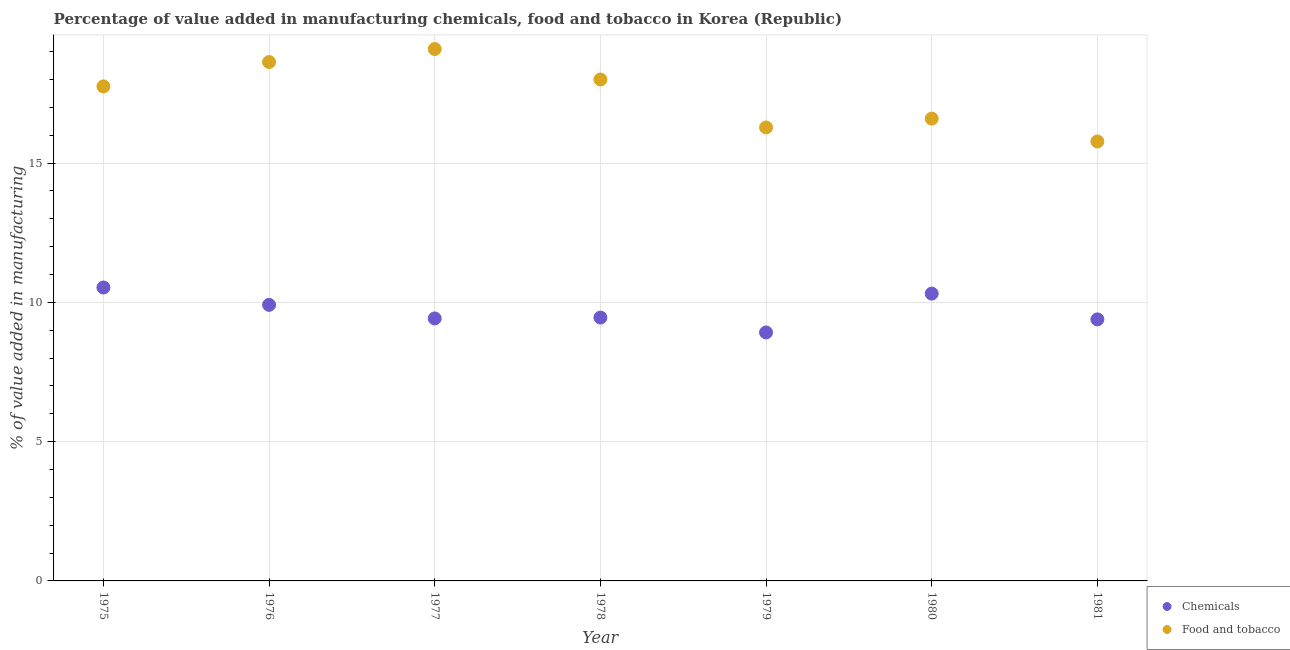How many different coloured dotlines are there?
Your answer should be very brief. 2. What is the value added by  manufacturing chemicals in 1976?
Offer a very short reply. 9.91. Across all years, what is the maximum value added by manufacturing food and tobacco?
Keep it short and to the point. 19.1. Across all years, what is the minimum value added by  manufacturing chemicals?
Keep it short and to the point. 8.92. In which year was the value added by  manufacturing chemicals minimum?
Provide a short and direct response. 1979. What is the total value added by  manufacturing chemicals in the graph?
Offer a terse response. 67.95. What is the difference between the value added by manufacturing food and tobacco in 1976 and that in 1979?
Your answer should be very brief. 2.35. What is the difference between the value added by  manufacturing chemicals in 1975 and the value added by manufacturing food and tobacco in 1980?
Offer a terse response. -6.06. What is the average value added by  manufacturing chemicals per year?
Ensure brevity in your answer.  9.71. In the year 1977, what is the difference between the value added by manufacturing food and tobacco and value added by  manufacturing chemicals?
Give a very brief answer. 9.67. What is the ratio of the value added by manufacturing food and tobacco in 1977 to that in 1981?
Make the answer very short. 1.21. Is the value added by manufacturing food and tobacco in 1975 less than that in 1979?
Ensure brevity in your answer.  No. Is the difference between the value added by  manufacturing chemicals in 1976 and 1979 greater than the difference between the value added by manufacturing food and tobacco in 1976 and 1979?
Provide a short and direct response. No. What is the difference between the highest and the second highest value added by  manufacturing chemicals?
Make the answer very short. 0.22. What is the difference between the highest and the lowest value added by  manufacturing chemicals?
Provide a succinct answer. 1.61. In how many years, is the value added by  manufacturing chemicals greater than the average value added by  manufacturing chemicals taken over all years?
Provide a short and direct response. 3. Is the sum of the value added by manufacturing food and tobacco in 1976 and 1979 greater than the maximum value added by  manufacturing chemicals across all years?
Give a very brief answer. Yes. Does the value added by manufacturing food and tobacco monotonically increase over the years?
Provide a succinct answer. No. Are the values on the major ticks of Y-axis written in scientific E-notation?
Provide a succinct answer. No. Does the graph contain any zero values?
Your answer should be compact. No. How many legend labels are there?
Provide a succinct answer. 2. How are the legend labels stacked?
Provide a short and direct response. Vertical. What is the title of the graph?
Your answer should be very brief. Percentage of value added in manufacturing chemicals, food and tobacco in Korea (Republic). Does "Sanitation services" appear as one of the legend labels in the graph?
Offer a very short reply. No. What is the label or title of the X-axis?
Provide a succinct answer. Year. What is the label or title of the Y-axis?
Your answer should be compact. % of value added in manufacturing. What is the % of value added in manufacturing in Chemicals in 1975?
Provide a short and direct response. 10.53. What is the % of value added in manufacturing of Food and tobacco in 1975?
Your answer should be very brief. 17.76. What is the % of value added in manufacturing of Chemicals in 1976?
Your answer should be very brief. 9.91. What is the % of value added in manufacturing in Food and tobacco in 1976?
Offer a terse response. 18.63. What is the % of value added in manufacturing in Chemicals in 1977?
Your answer should be very brief. 9.42. What is the % of value added in manufacturing in Food and tobacco in 1977?
Offer a very short reply. 19.1. What is the % of value added in manufacturing of Chemicals in 1978?
Keep it short and to the point. 9.46. What is the % of value added in manufacturing of Food and tobacco in 1978?
Ensure brevity in your answer.  18. What is the % of value added in manufacturing of Chemicals in 1979?
Your answer should be very brief. 8.92. What is the % of value added in manufacturing of Food and tobacco in 1979?
Your answer should be compact. 16.28. What is the % of value added in manufacturing in Chemicals in 1980?
Offer a very short reply. 10.31. What is the % of value added in manufacturing in Food and tobacco in 1980?
Make the answer very short. 16.6. What is the % of value added in manufacturing in Chemicals in 1981?
Offer a very short reply. 9.39. What is the % of value added in manufacturing in Food and tobacco in 1981?
Ensure brevity in your answer.  15.78. Across all years, what is the maximum % of value added in manufacturing of Chemicals?
Give a very brief answer. 10.53. Across all years, what is the maximum % of value added in manufacturing of Food and tobacco?
Give a very brief answer. 19.1. Across all years, what is the minimum % of value added in manufacturing in Chemicals?
Make the answer very short. 8.92. Across all years, what is the minimum % of value added in manufacturing of Food and tobacco?
Provide a short and direct response. 15.78. What is the total % of value added in manufacturing in Chemicals in the graph?
Provide a short and direct response. 67.95. What is the total % of value added in manufacturing of Food and tobacco in the graph?
Your answer should be very brief. 122.14. What is the difference between the % of value added in manufacturing in Chemicals in 1975 and that in 1976?
Make the answer very short. 0.62. What is the difference between the % of value added in manufacturing of Food and tobacco in 1975 and that in 1976?
Ensure brevity in your answer.  -0.87. What is the difference between the % of value added in manufacturing in Chemicals in 1975 and that in 1977?
Your answer should be very brief. 1.11. What is the difference between the % of value added in manufacturing in Food and tobacco in 1975 and that in 1977?
Your response must be concise. -1.34. What is the difference between the % of value added in manufacturing in Chemicals in 1975 and that in 1978?
Offer a terse response. 1.08. What is the difference between the % of value added in manufacturing of Food and tobacco in 1975 and that in 1978?
Make the answer very short. -0.25. What is the difference between the % of value added in manufacturing of Chemicals in 1975 and that in 1979?
Give a very brief answer. 1.61. What is the difference between the % of value added in manufacturing of Food and tobacco in 1975 and that in 1979?
Make the answer very short. 1.47. What is the difference between the % of value added in manufacturing of Chemicals in 1975 and that in 1980?
Your answer should be very brief. 0.22. What is the difference between the % of value added in manufacturing in Food and tobacco in 1975 and that in 1980?
Offer a terse response. 1.16. What is the difference between the % of value added in manufacturing in Chemicals in 1975 and that in 1981?
Your response must be concise. 1.14. What is the difference between the % of value added in manufacturing of Food and tobacco in 1975 and that in 1981?
Offer a terse response. 1.98. What is the difference between the % of value added in manufacturing of Chemicals in 1976 and that in 1977?
Give a very brief answer. 0.49. What is the difference between the % of value added in manufacturing in Food and tobacco in 1976 and that in 1977?
Give a very brief answer. -0.47. What is the difference between the % of value added in manufacturing in Chemicals in 1976 and that in 1978?
Your answer should be compact. 0.46. What is the difference between the % of value added in manufacturing in Food and tobacco in 1976 and that in 1978?
Keep it short and to the point. 0.63. What is the difference between the % of value added in manufacturing of Chemicals in 1976 and that in 1979?
Your response must be concise. 0.99. What is the difference between the % of value added in manufacturing of Food and tobacco in 1976 and that in 1979?
Provide a short and direct response. 2.35. What is the difference between the % of value added in manufacturing of Chemicals in 1976 and that in 1980?
Make the answer very short. -0.4. What is the difference between the % of value added in manufacturing of Food and tobacco in 1976 and that in 1980?
Keep it short and to the point. 2.03. What is the difference between the % of value added in manufacturing of Chemicals in 1976 and that in 1981?
Your answer should be compact. 0.52. What is the difference between the % of value added in manufacturing of Food and tobacco in 1976 and that in 1981?
Offer a very short reply. 2.85. What is the difference between the % of value added in manufacturing of Chemicals in 1977 and that in 1978?
Give a very brief answer. -0.03. What is the difference between the % of value added in manufacturing in Food and tobacco in 1977 and that in 1978?
Offer a terse response. 1.09. What is the difference between the % of value added in manufacturing in Chemicals in 1977 and that in 1979?
Your response must be concise. 0.5. What is the difference between the % of value added in manufacturing in Food and tobacco in 1977 and that in 1979?
Give a very brief answer. 2.81. What is the difference between the % of value added in manufacturing in Chemicals in 1977 and that in 1980?
Make the answer very short. -0.89. What is the difference between the % of value added in manufacturing of Food and tobacco in 1977 and that in 1980?
Offer a terse response. 2.5. What is the difference between the % of value added in manufacturing in Chemicals in 1977 and that in 1981?
Your answer should be compact. 0.03. What is the difference between the % of value added in manufacturing in Food and tobacco in 1977 and that in 1981?
Your answer should be compact. 3.32. What is the difference between the % of value added in manufacturing in Chemicals in 1978 and that in 1979?
Your answer should be very brief. 0.54. What is the difference between the % of value added in manufacturing of Food and tobacco in 1978 and that in 1979?
Provide a succinct answer. 1.72. What is the difference between the % of value added in manufacturing of Chemicals in 1978 and that in 1980?
Make the answer very short. -0.86. What is the difference between the % of value added in manufacturing of Food and tobacco in 1978 and that in 1980?
Give a very brief answer. 1.4. What is the difference between the % of value added in manufacturing of Chemicals in 1978 and that in 1981?
Ensure brevity in your answer.  0.07. What is the difference between the % of value added in manufacturing of Food and tobacco in 1978 and that in 1981?
Offer a very short reply. 2.22. What is the difference between the % of value added in manufacturing of Chemicals in 1979 and that in 1980?
Your answer should be compact. -1.39. What is the difference between the % of value added in manufacturing in Food and tobacco in 1979 and that in 1980?
Your answer should be compact. -0.32. What is the difference between the % of value added in manufacturing of Chemicals in 1979 and that in 1981?
Ensure brevity in your answer.  -0.47. What is the difference between the % of value added in manufacturing in Food and tobacco in 1979 and that in 1981?
Ensure brevity in your answer.  0.5. What is the difference between the % of value added in manufacturing of Chemicals in 1980 and that in 1981?
Offer a very short reply. 0.92. What is the difference between the % of value added in manufacturing of Food and tobacco in 1980 and that in 1981?
Give a very brief answer. 0.82. What is the difference between the % of value added in manufacturing in Chemicals in 1975 and the % of value added in manufacturing in Food and tobacco in 1976?
Your answer should be compact. -8.1. What is the difference between the % of value added in manufacturing of Chemicals in 1975 and the % of value added in manufacturing of Food and tobacco in 1977?
Offer a very short reply. -8.56. What is the difference between the % of value added in manufacturing in Chemicals in 1975 and the % of value added in manufacturing in Food and tobacco in 1978?
Offer a terse response. -7.47. What is the difference between the % of value added in manufacturing in Chemicals in 1975 and the % of value added in manufacturing in Food and tobacco in 1979?
Give a very brief answer. -5.75. What is the difference between the % of value added in manufacturing in Chemicals in 1975 and the % of value added in manufacturing in Food and tobacco in 1980?
Offer a terse response. -6.06. What is the difference between the % of value added in manufacturing in Chemicals in 1975 and the % of value added in manufacturing in Food and tobacco in 1981?
Keep it short and to the point. -5.24. What is the difference between the % of value added in manufacturing of Chemicals in 1976 and the % of value added in manufacturing of Food and tobacco in 1977?
Provide a succinct answer. -9.18. What is the difference between the % of value added in manufacturing of Chemicals in 1976 and the % of value added in manufacturing of Food and tobacco in 1978?
Your response must be concise. -8.09. What is the difference between the % of value added in manufacturing in Chemicals in 1976 and the % of value added in manufacturing in Food and tobacco in 1979?
Offer a very short reply. -6.37. What is the difference between the % of value added in manufacturing in Chemicals in 1976 and the % of value added in manufacturing in Food and tobacco in 1980?
Your answer should be compact. -6.69. What is the difference between the % of value added in manufacturing of Chemicals in 1976 and the % of value added in manufacturing of Food and tobacco in 1981?
Your response must be concise. -5.87. What is the difference between the % of value added in manufacturing of Chemicals in 1977 and the % of value added in manufacturing of Food and tobacco in 1978?
Provide a short and direct response. -8.58. What is the difference between the % of value added in manufacturing in Chemicals in 1977 and the % of value added in manufacturing in Food and tobacco in 1979?
Give a very brief answer. -6.86. What is the difference between the % of value added in manufacturing in Chemicals in 1977 and the % of value added in manufacturing in Food and tobacco in 1980?
Your answer should be very brief. -7.17. What is the difference between the % of value added in manufacturing in Chemicals in 1977 and the % of value added in manufacturing in Food and tobacco in 1981?
Make the answer very short. -6.35. What is the difference between the % of value added in manufacturing in Chemicals in 1978 and the % of value added in manufacturing in Food and tobacco in 1979?
Provide a succinct answer. -6.83. What is the difference between the % of value added in manufacturing in Chemicals in 1978 and the % of value added in manufacturing in Food and tobacco in 1980?
Provide a short and direct response. -7.14. What is the difference between the % of value added in manufacturing in Chemicals in 1978 and the % of value added in manufacturing in Food and tobacco in 1981?
Provide a short and direct response. -6.32. What is the difference between the % of value added in manufacturing of Chemicals in 1979 and the % of value added in manufacturing of Food and tobacco in 1980?
Offer a terse response. -7.68. What is the difference between the % of value added in manufacturing of Chemicals in 1979 and the % of value added in manufacturing of Food and tobacco in 1981?
Give a very brief answer. -6.86. What is the difference between the % of value added in manufacturing in Chemicals in 1980 and the % of value added in manufacturing in Food and tobacco in 1981?
Offer a very short reply. -5.46. What is the average % of value added in manufacturing of Chemicals per year?
Give a very brief answer. 9.71. What is the average % of value added in manufacturing in Food and tobacco per year?
Provide a short and direct response. 17.45. In the year 1975, what is the difference between the % of value added in manufacturing in Chemicals and % of value added in manufacturing in Food and tobacco?
Make the answer very short. -7.22. In the year 1976, what is the difference between the % of value added in manufacturing of Chemicals and % of value added in manufacturing of Food and tobacco?
Offer a terse response. -8.72. In the year 1977, what is the difference between the % of value added in manufacturing of Chemicals and % of value added in manufacturing of Food and tobacco?
Make the answer very short. -9.67. In the year 1978, what is the difference between the % of value added in manufacturing of Chemicals and % of value added in manufacturing of Food and tobacco?
Offer a terse response. -8.55. In the year 1979, what is the difference between the % of value added in manufacturing in Chemicals and % of value added in manufacturing in Food and tobacco?
Keep it short and to the point. -7.36. In the year 1980, what is the difference between the % of value added in manufacturing in Chemicals and % of value added in manufacturing in Food and tobacco?
Your answer should be compact. -6.28. In the year 1981, what is the difference between the % of value added in manufacturing of Chemicals and % of value added in manufacturing of Food and tobacco?
Your response must be concise. -6.39. What is the ratio of the % of value added in manufacturing of Chemicals in 1975 to that in 1976?
Your answer should be very brief. 1.06. What is the ratio of the % of value added in manufacturing in Food and tobacco in 1975 to that in 1976?
Provide a succinct answer. 0.95. What is the ratio of the % of value added in manufacturing in Chemicals in 1975 to that in 1977?
Offer a terse response. 1.12. What is the ratio of the % of value added in manufacturing of Food and tobacco in 1975 to that in 1977?
Provide a short and direct response. 0.93. What is the ratio of the % of value added in manufacturing in Chemicals in 1975 to that in 1978?
Provide a short and direct response. 1.11. What is the ratio of the % of value added in manufacturing of Food and tobacco in 1975 to that in 1978?
Your answer should be compact. 0.99. What is the ratio of the % of value added in manufacturing of Chemicals in 1975 to that in 1979?
Your answer should be compact. 1.18. What is the ratio of the % of value added in manufacturing of Food and tobacco in 1975 to that in 1979?
Provide a succinct answer. 1.09. What is the ratio of the % of value added in manufacturing in Chemicals in 1975 to that in 1980?
Make the answer very short. 1.02. What is the ratio of the % of value added in manufacturing in Food and tobacco in 1975 to that in 1980?
Offer a very short reply. 1.07. What is the ratio of the % of value added in manufacturing in Chemicals in 1975 to that in 1981?
Offer a very short reply. 1.12. What is the ratio of the % of value added in manufacturing of Food and tobacco in 1975 to that in 1981?
Provide a succinct answer. 1.13. What is the ratio of the % of value added in manufacturing in Chemicals in 1976 to that in 1977?
Provide a short and direct response. 1.05. What is the ratio of the % of value added in manufacturing in Food and tobacco in 1976 to that in 1977?
Your response must be concise. 0.98. What is the ratio of the % of value added in manufacturing of Chemicals in 1976 to that in 1978?
Offer a very short reply. 1.05. What is the ratio of the % of value added in manufacturing in Food and tobacco in 1976 to that in 1978?
Make the answer very short. 1.03. What is the ratio of the % of value added in manufacturing of Food and tobacco in 1976 to that in 1979?
Your response must be concise. 1.14. What is the ratio of the % of value added in manufacturing of Chemicals in 1976 to that in 1980?
Provide a succinct answer. 0.96. What is the ratio of the % of value added in manufacturing of Food and tobacco in 1976 to that in 1980?
Give a very brief answer. 1.12. What is the ratio of the % of value added in manufacturing of Chemicals in 1976 to that in 1981?
Offer a very short reply. 1.06. What is the ratio of the % of value added in manufacturing in Food and tobacco in 1976 to that in 1981?
Your answer should be very brief. 1.18. What is the ratio of the % of value added in manufacturing of Chemicals in 1977 to that in 1978?
Provide a short and direct response. 1. What is the ratio of the % of value added in manufacturing in Food and tobacco in 1977 to that in 1978?
Keep it short and to the point. 1.06. What is the ratio of the % of value added in manufacturing in Chemicals in 1977 to that in 1979?
Provide a succinct answer. 1.06. What is the ratio of the % of value added in manufacturing of Food and tobacco in 1977 to that in 1979?
Ensure brevity in your answer.  1.17. What is the ratio of the % of value added in manufacturing of Chemicals in 1977 to that in 1980?
Provide a short and direct response. 0.91. What is the ratio of the % of value added in manufacturing in Food and tobacco in 1977 to that in 1980?
Ensure brevity in your answer.  1.15. What is the ratio of the % of value added in manufacturing of Food and tobacco in 1977 to that in 1981?
Your response must be concise. 1.21. What is the ratio of the % of value added in manufacturing in Chemicals in 1978 to that in 1979?
Your answer should be compact. 1.06. What is the ratio of the % of value added in manufacturing in Food and tobacco in 1978 to that in 1979?
Ensure brevity in your answer.  1.11. What is the ratio of the % of value added in manufacturing of Chemicals in 1978 to that in 1980?
Your response must be concise. 0.92. What is the ratio of the % of value added in manufacturing of Food and tobacco in 1978 to that in 1980?
Offer a very short reply. 1.08. What is the ratio of the % of value added in manufacturing of Food and tobacco in 1978 to that in 1981?
Give a very brief answer. 1.14. What is the ratio of the % of value added in manufacturing of Chemicals in 1979 to that in 1980?
Provide a short and direct response. 0.86. What is the ratio of the % of value added in manufacturing in Food and tobacco in 1979 to that in 1980?
Your response must be concise. 0.98. What is the ratio of the % of value added in manufacturing in Food and tobacco in 1979 to that in 1981?
Keep it short and to the point. 1.03. What is the ratio of the % of value added in manufacturing of Chemicals in 1980 to that in 1981?
Offer a terse response. 1.1. What is the ratio of the % of value added in manufacturing of Food and tobacco in 1980 to that in 1981?
Your response must be concise. 1.05. What is the difference between the highest and the second highest % of value added in manufacturing of Chemicals?
Your answer should be compact. 0.22. What is the difference between the highest and the second highest % of value added in manufacturing in Food and tobacco?
Make the answer very short. 0.47. What is the difference between the highest and the lowest % of value added in manufacturing of Chemicals?
Give a very brief answer. 1.61. What is the difference between the highest and the lowest % of value added in manufacturing in Food and tobacco?
Make the answer very short. 3.32. 